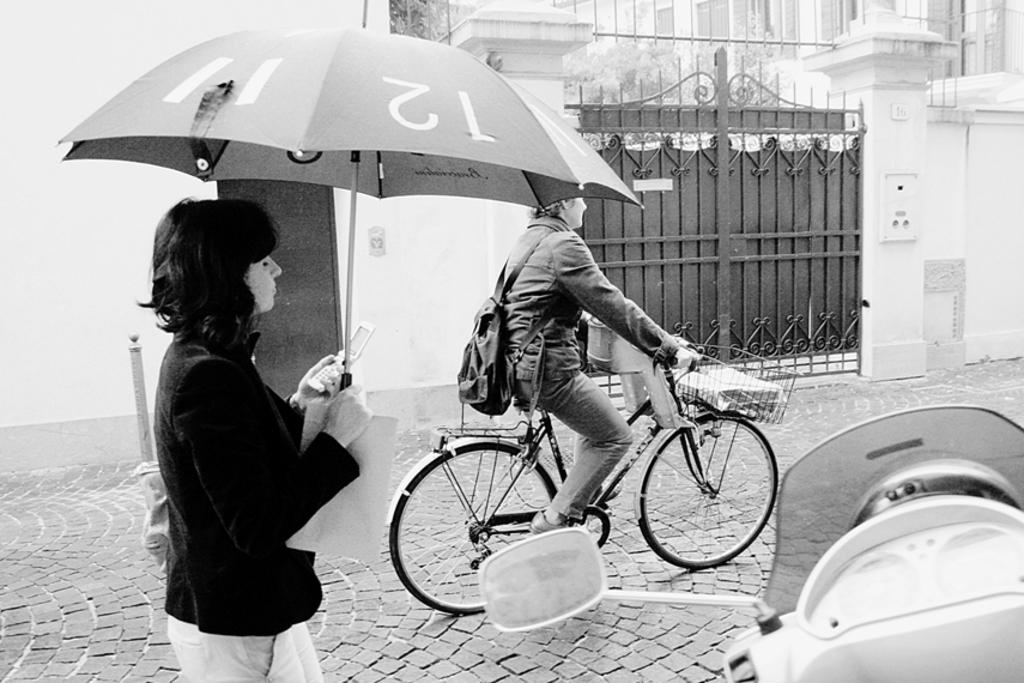How many people are present in the image? There are two people in the image. What is one person doing in the image? One person is riding a bicycle. What is the other person doing in the image? The other person is walking. What type of leather material can be seen on the road in the image? There is no leather material present on the road in the image. How does the person riding the bicycle sneeze while riding? The person riding the bicycle is not sneezing in the image, and there is no indication of any sneezing activity. 